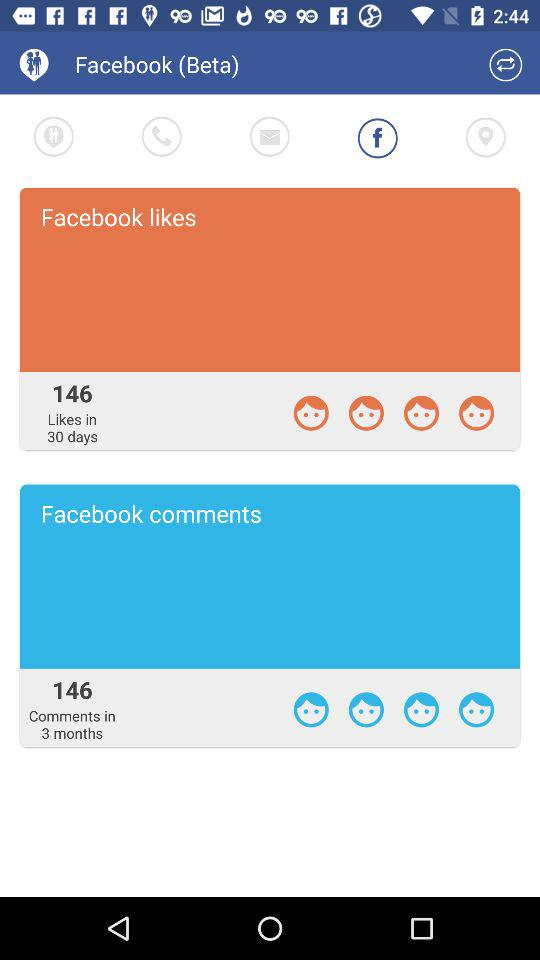In how many days were those likes received? Those likes were received in 30 days. 